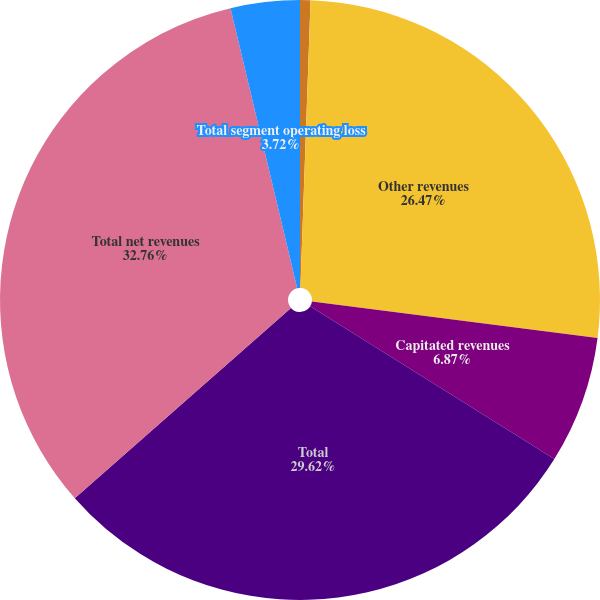Convert chart to OTSL. <chart><loc_0><loc_0><loc_500><loc_500><pie_chart><fcel>Net patient service revenues<fcel>Other revenues<fcel>Capitated revenues<fcel>Total<fcel>Total net revenues<fcel>Total segment operating loss<nl><fcel>0.56%<fcel>26.47%<fcel>6.87%<fcel>29.62%<fcel>32.77%<fcel>3.72%<nl></chart> 